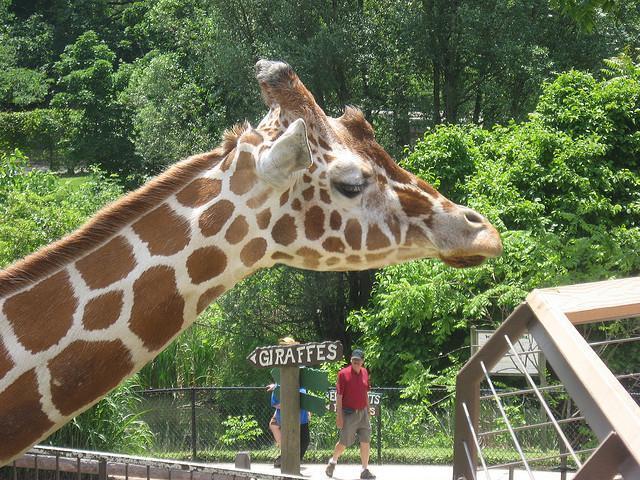How many elephants can you see?
Give a very brief answer. 0. 